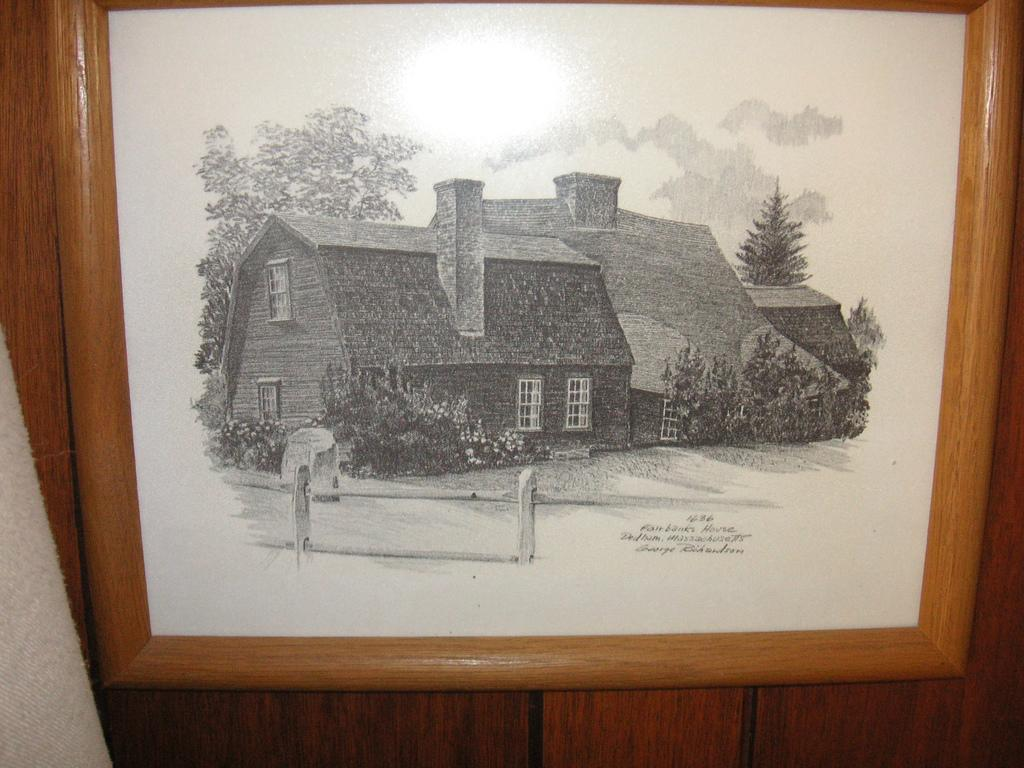What is depicted in the image? There is a drawing in the image. How is the drawing displayed? The drawing is in a frame. What type of wall is the frame mounted on? The frame is on a wooden wall. What type of food is being cooked on the sidewalk in the image? There is no mention of cooking or a sidewalk in the image; it features a drawing in a frame on a wooden wall. 